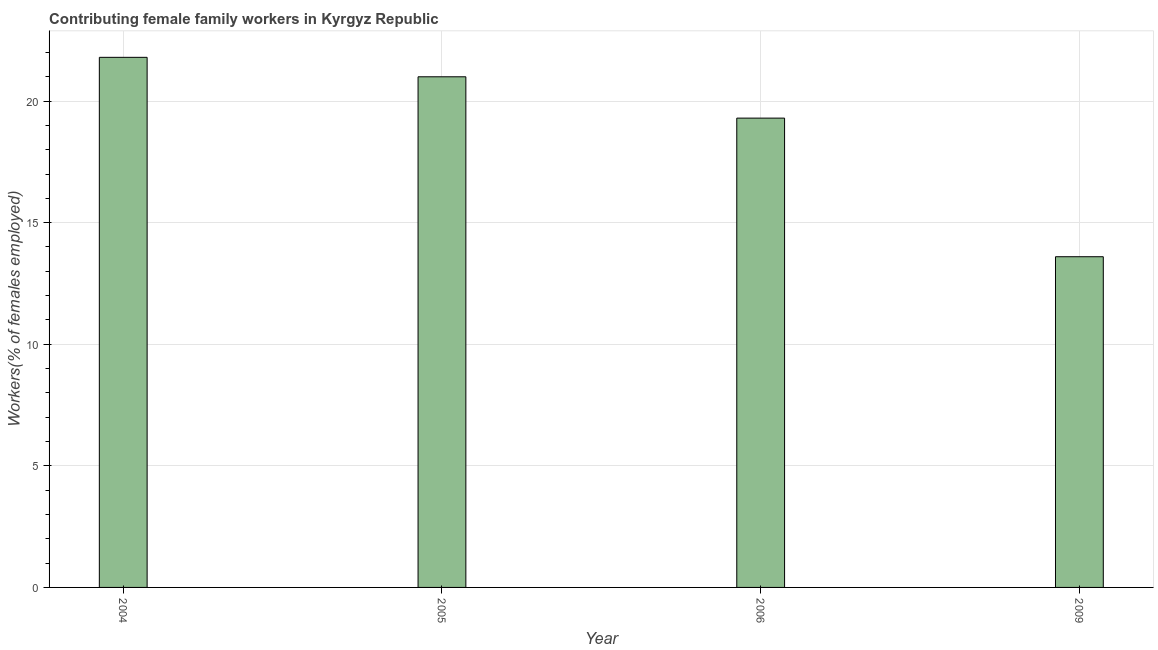Does the graph contain grids?
Your answer should be very brief. Yes. What is the title of the graph?
Offer a terse response. Contributing female family workers in Kyrgyz Republic. What is the label or title of the Y-axis?
Provide a short and direct response. Workers(% of females employed). What is the contributing female family workers in 2004?
Provide a short and direct response. 21.8. Across all years, what is the maximum contributing female family workers?
Offer a terse response. 21.8. Across all years, what is the minimum contributing female family workers?
Your answer should be compact. 13.6. What is the sum of the contributing female family workers?
Your answer should be compact. 75.7. What is the difference between the contributing female family workers in 2004 and 2009?
Offer a very short reply. 8.2. What is the average contributing female family workers per year?
Offer a terse response. 18.93. What is the median contributing female family workers?
Give a very brief answer. 20.15. Do a majority of the years between 2004 and 2005 (inclusive) have contributing female family workers greater than 18 %?
Your answer should be very brief. Yes. What is the ratio of the contributing female family workers in 2005 to that in 2006?
Provide a succinct answer. 1.09. Is the contributing female family workers in 2005 less than that in 2006?
Keep it short and to the point. No. Is the difference between the contributing female family workers in 2004 and 2006 greater than the difference between any two years?
Your answer should be compact. No. What is the difference between the highest and the second highest contributing female family workers?
Give a very brief answer. 0.8. How many bars are there?
Provide a succinct answer. 4. How many years are there in the graph?
Ensure brevity in your answer.  4. What is the difference between two consecutive major ticks on the Y-axis?
Offer a very short reply. 5. What is the Workers(% of females employed) in 2004?
Provide a short and direct response. 21.8. What is the Workers(% of females employed) of 2006?
Keep it short and to the point. 19.3. What is the Workers(% of females employed) of 2009?
Give a very brief answer. 13.6. What is the difference between the Workers(% of females employed) in 2006 and 2009?
Provide a short and direct response. 5.7. What is the ratio of the Workers(% of females employed) in 2004 to that in 2005?
Keep it short and to the point. 1.04. What is the ratio of the Workers(% of females employed) in 2004 to that in 2006?
Make the answer very short. 1.13. What is the ratio of the Workers(% of females employed) in 2004 to that in 2009?
Offer a very short reply. 1.6. What is the ratio of the Workers(% of females employed) in 2005 to that in 2006?
Offer a terse response. 1.09. What is the ratio of the Workers(% of females employed) in 2005 to that in 2009?
Your answer should be very brief. 1.54. What is the ratio of the Workers(% of females employed) in 2006 to that in 2009?
Provide a succinct answer. 1.42. 